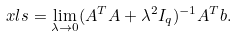<formula> <loc_0><loc_0><loc_500><loc_500>\ x l s = \lim _ { \lambda \to 0 } ( A ^ { T } A + \lambda ^ { 2 } I _ { q } ) ^ { - 1 } A ^ { T } b .</formula> 